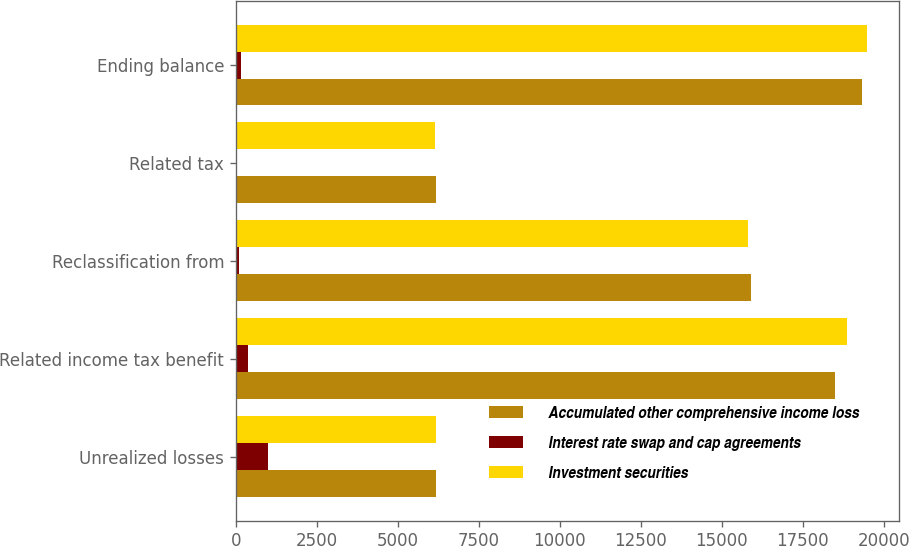Convert chart. <chart><loc_0><loc_0><loc_500><loc_500><stacked_bar_chart><ecel><fcel>Unrealized losses<fcel>Related income tax benefit<fcel>Reclassification from<fcel>Related tax<fcel>Ending balance<nl><fcel>Accumulated other comprehensive income loss<fcel>6190<fcel>18495<fcel>15911<fcel>6190<fcel>19328<nl><fcel>Interest rate swap and cap agreements<fcel>986<fcel>384<fcel>93<fcel>36<fcel>156<nl><fcel>Investment securities<fcel>6190<fcel>18879<fcel>15818<fcel>6154<fcel>19484<nl></chart> 